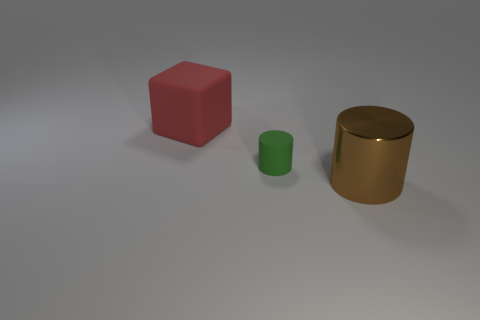Add 2 big purple cylinders. How many objects exist? 5 Subtract all cubes. How many objects are left? 2 Subtract all green things. Subtract all large cyan shiny objects. How many objects are left? 2 Add 1 small green cylinders. How many small green cylinders are left? 2 Add 3 rubber cylinders. How many rubber cylinders exist? 4 Subtract 0 brown blocks. How many objects are left? 3 